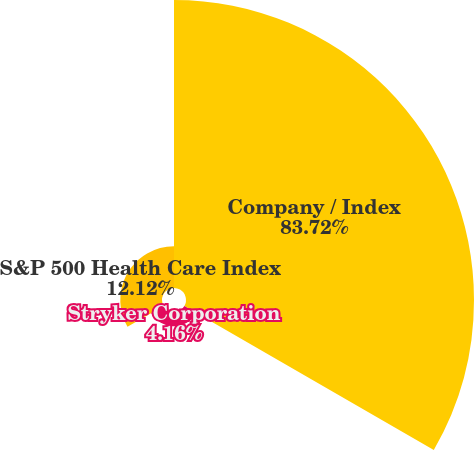Convert chart. <chart><loc_0><loc_0><loc_500><loc_500><pie_chart><fcel>Company / Index<fcel>Stryker Corporation<fcel>S&P 500 Health Care Index<nl><fcel>83.72%<fcel>4.16%<fcel>12.12%<nl></chart> 